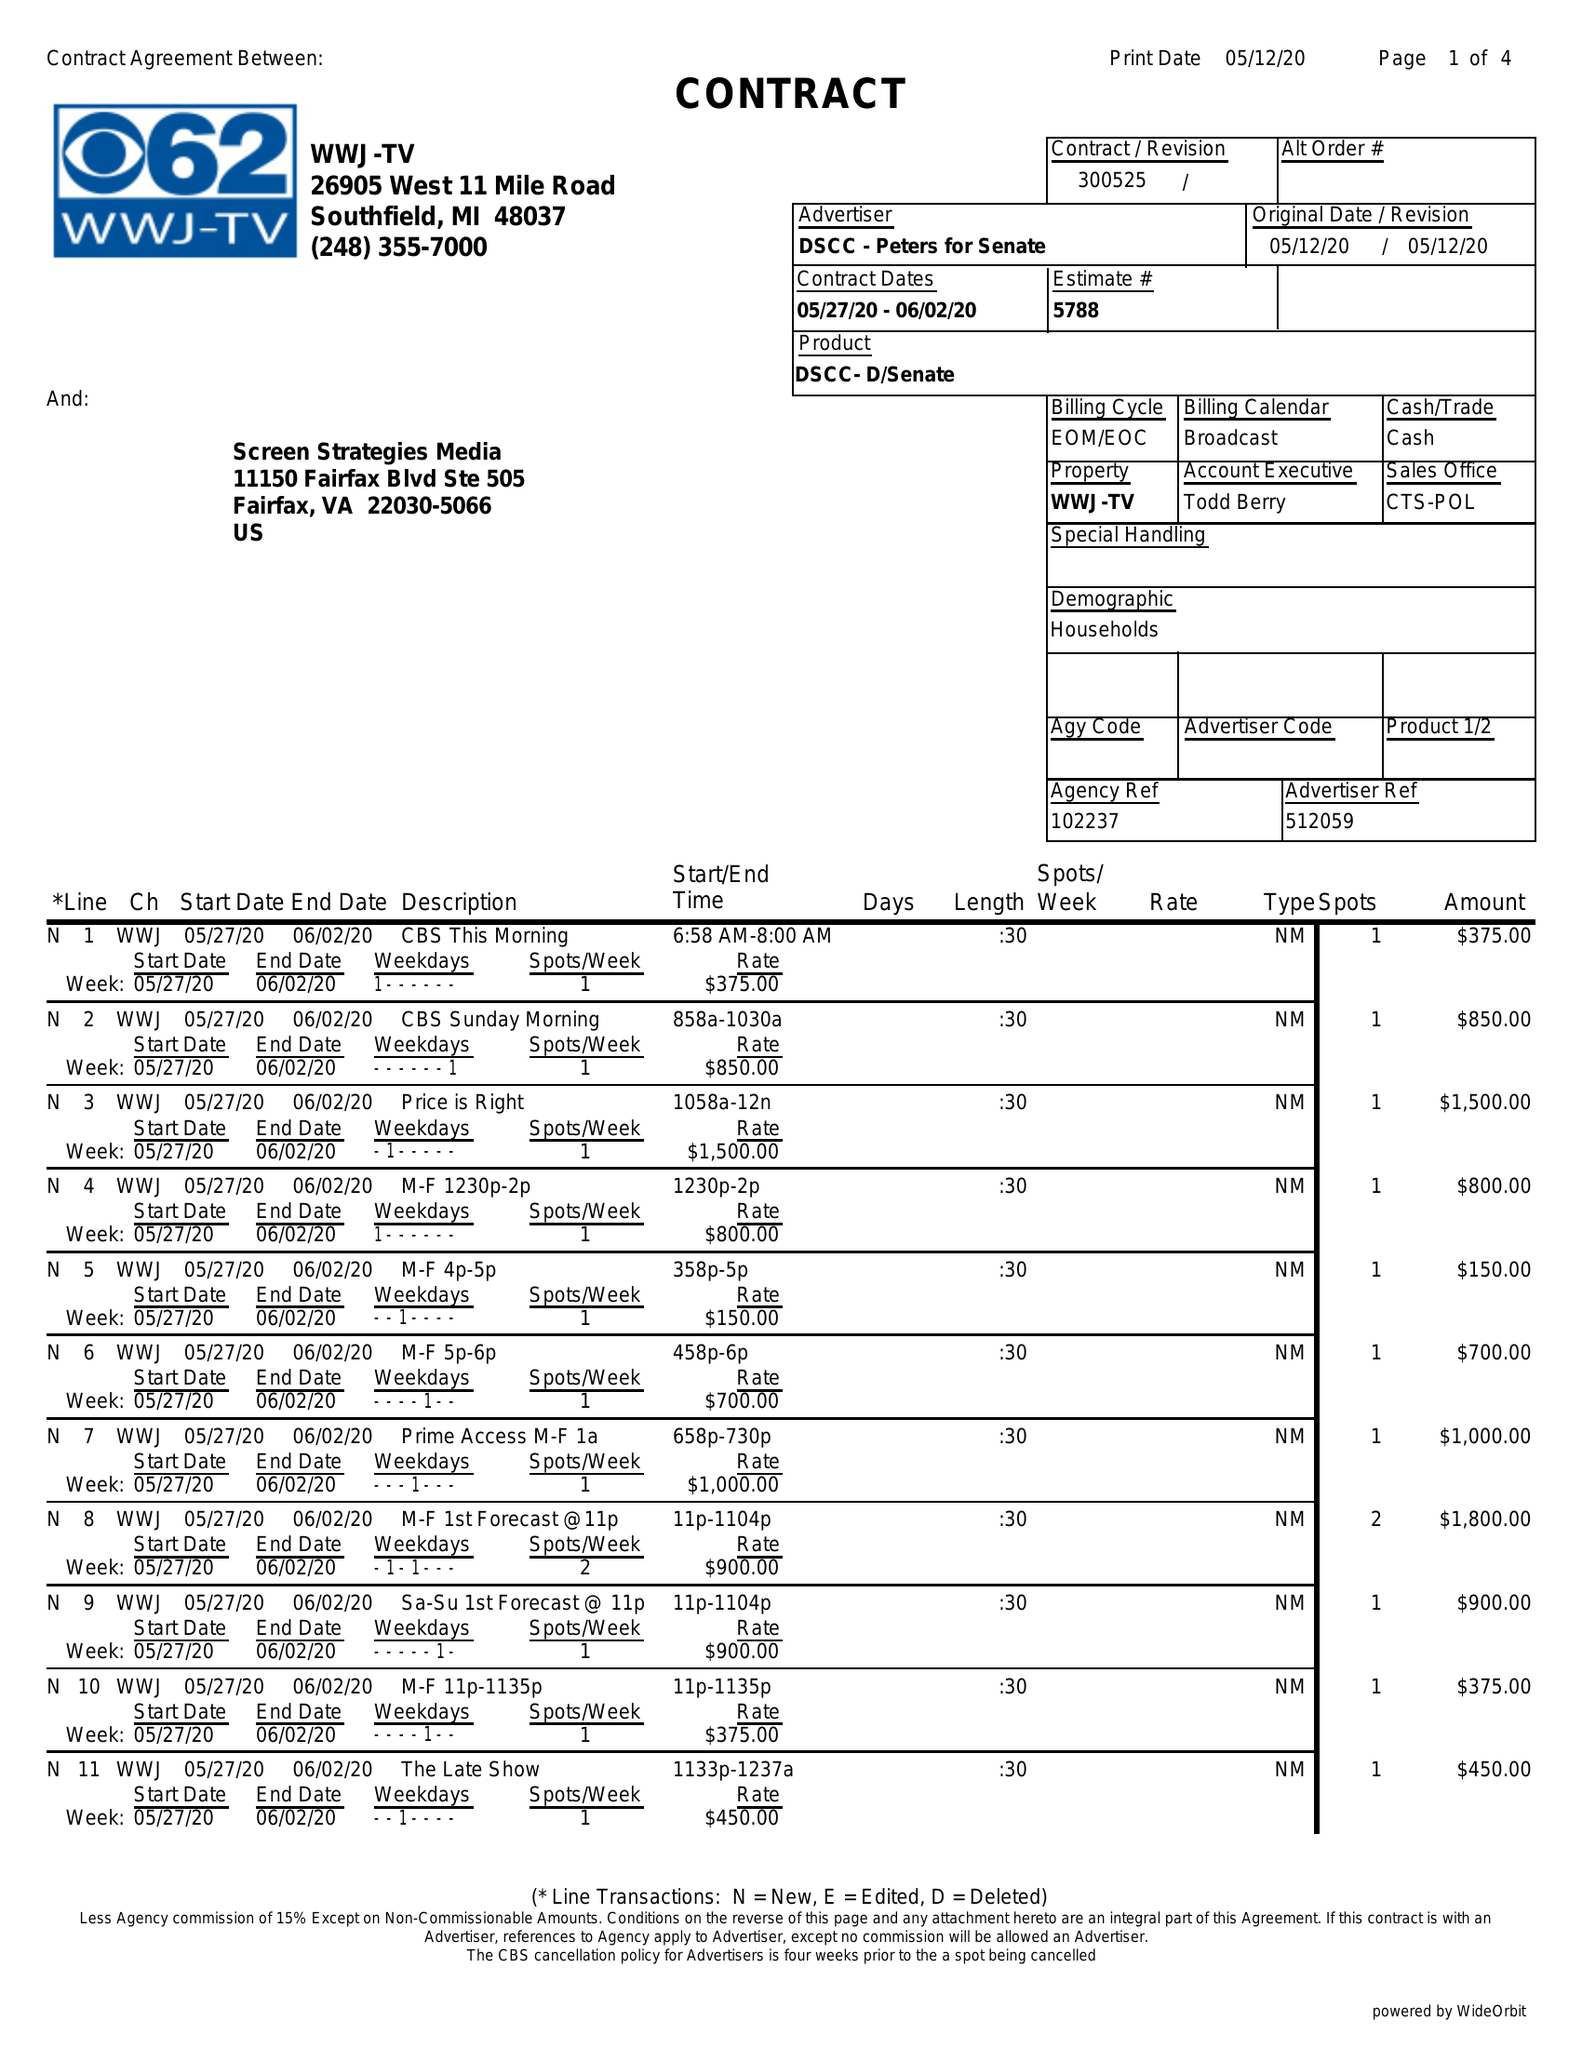What is the value for the flight_from?
Answer the question using a single word or phrase. 05/27/20 